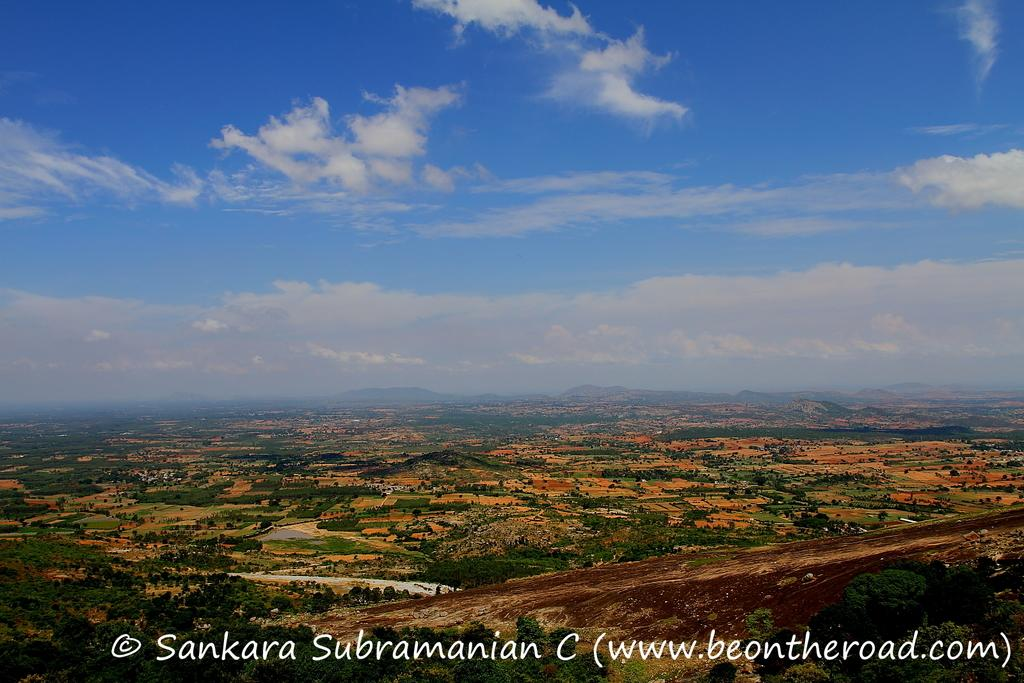What can be found in the image that contains written information? There is text in the image. What type of natural environment is visible in the image? There is grass, trees, and mountains in the image. What type of structures are present in the image? There are houses in the image. What color is the sky in the image? The sky is blue and visible at the top of the image. From where was the image likely taken? The image is likely taken from the ground. What type of chair is depicted in the image? There is no chair present in the image. What type of cabbage can be seen growing in the image? There is no cabbage present in the image. 